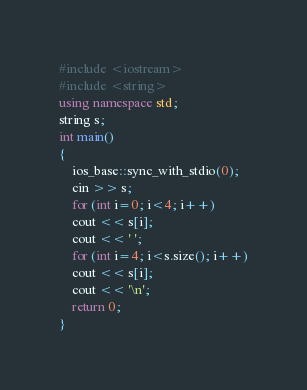<code> <loc_0><loc_0><loc_500><loc_500><_C++_>#include <iostream>
#include <string>
using namespace std;
string s;
int main() 
{
	ios_base::sync_with_stdio(0);
	cin >> s;
	for (int i=0; i<4; i++)
	cout << s[i];
	cout << ' ';
	for (int i=4; i<s.size(); i++)
	cout << s[i];
	cout << '\n';
	return 0;
}</code> 